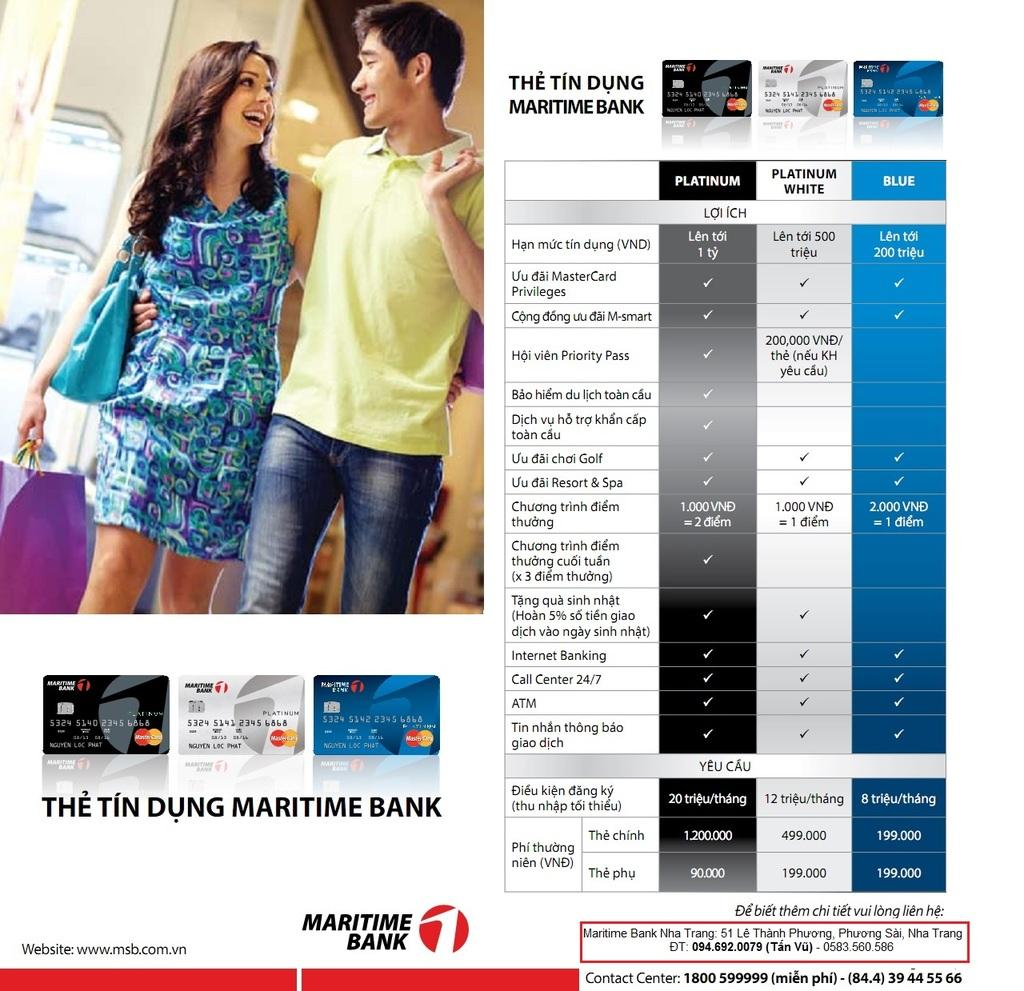What is the main subject of the poster in the image? The poster depicts people standing and holding bags. How many Mastercards are visible in the image? There are three Mastercards in the image. What other item can be seen in the image besides the poster and Mastercards? There is a chapter plan sheet in the image. What type of brick is used to build the wall behind the poster? There is no wall or brick visible in the image; the focus is on the poster, Mastercards, and chapter plan sheet. 